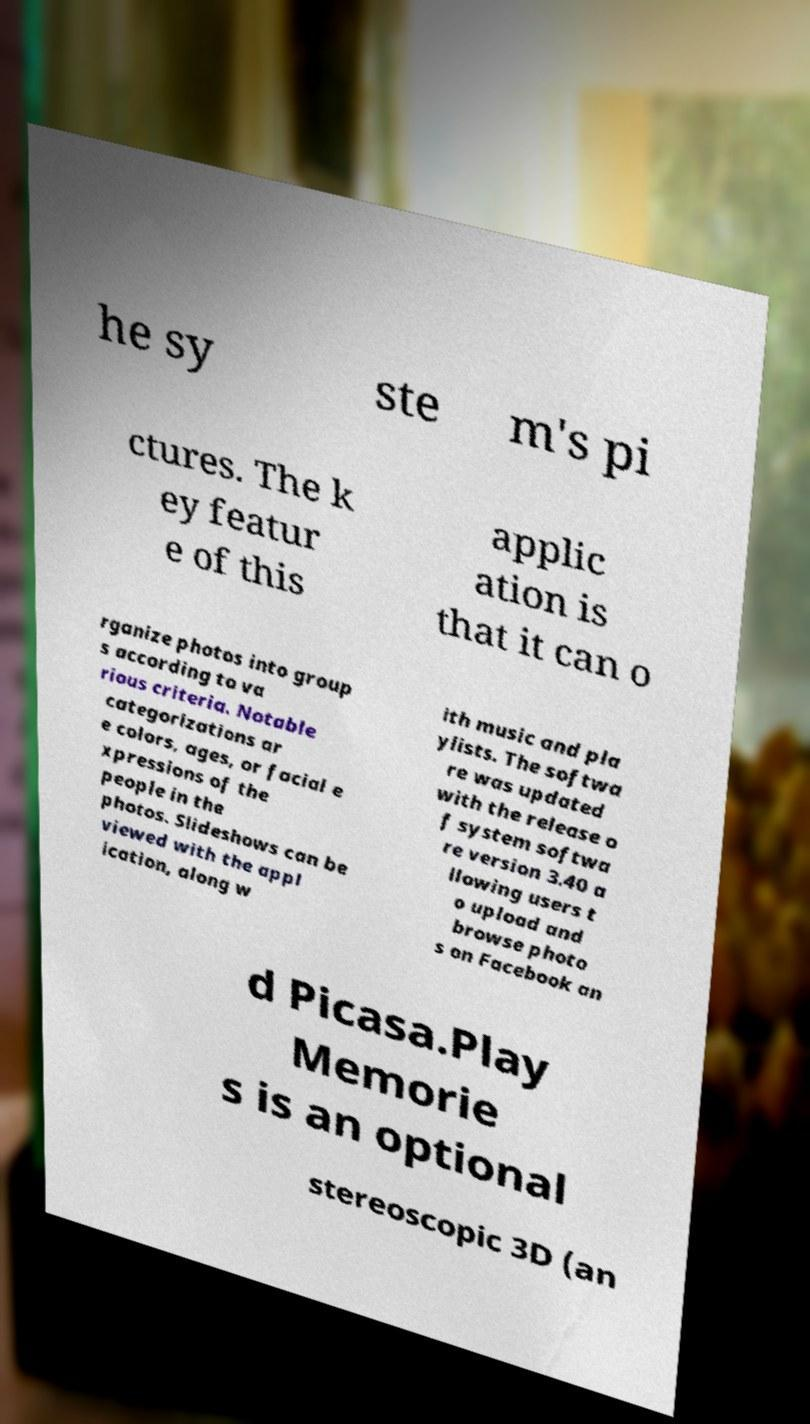I need the written content from this picture converted into text. Can you do that? he sy ste m's pi ctures. The k ey featur e of this applic ation is that it can o rganize photos into group s according to va rious criteria. Notable categorizations ar e colors, ages, or facial e xpressions of the people in the photos. Slideshows can be viewed with the appl ication, along w ith music and pla ylists. The softwa re was updated with the release o f system softwa re version 3.40 a llowing users t o upload and browse photo s on Facebook an d Picasa.Play Memorie s is an optional stereoscopic 3D (an 